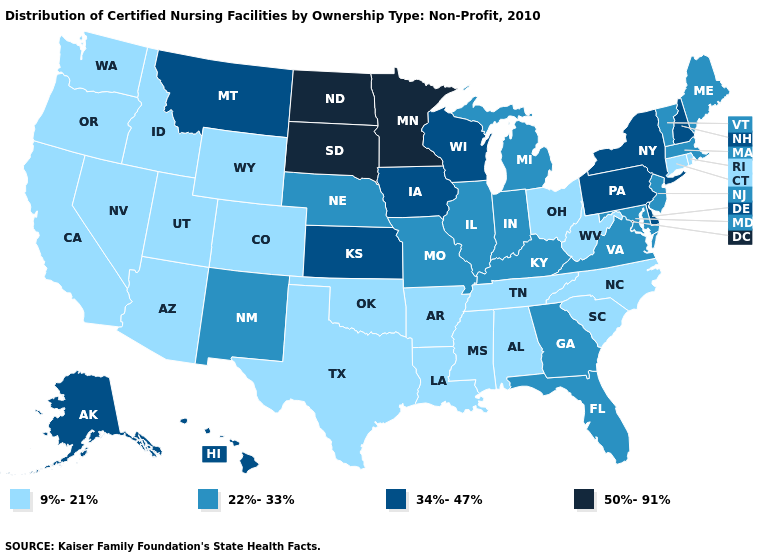Name the states that have a value in the range 9%-21%?
Give a very brief answer. Alabama, Arizona, Arkansas, California, Colorado, Connecticut, Idaho, Louisiana, Mississippi, Nevada, North Carolina, Ohio, Oklahoma, Oregon, Rhode Island, South Carolina, Tennessee, Texas, Utah, Washington, West Virginia, Wyoming. Does the first symbol in the legend represent the smallest category?
Give a very brief answer. Yes. Which states hav the highest value in the West?
Quick response, please. Alaska, Hawaii, Montana. What is the value of Illinois?
Give a very brief answer. 22%-33%. What is the lowest value in states that border Maine?
Answer briefly. 34%-47%. What is the value of New York?
Keep it brief. 34%-47%. Which states hav the highest value in the South?
Keep it brief. Delaware. What is the value of Oklahoma?
Be succinct. 9%-21%. What is the value of Illinois?
Answer briefly. 22%-33%. Does Kentucky have a lower value than Pennsylvania?
Quick response, please. Yes. What is the value of New Mexico?
Quick response, please. 22%-33%. Name the states that have a value in the range 9%-21%?
Short answer required. Alabama, Arizona, Arkansas, California, Colorado, Connecticut, Idaho, Louisiana, Mississippi, Nevada, North Carolina, Ohio, Oklahoma, Oregon, Rhode Island, South Carolina, Tennessee, Texas, Utah, Washington, West Virginia, Wyoming. What is the value of Connecticut?
Concise answer only. 9%-21%. Is the legend a continuous bar?
Short answer required. No. Does Ohio have the same value as Wyoming?
Be succinct. Yes. 